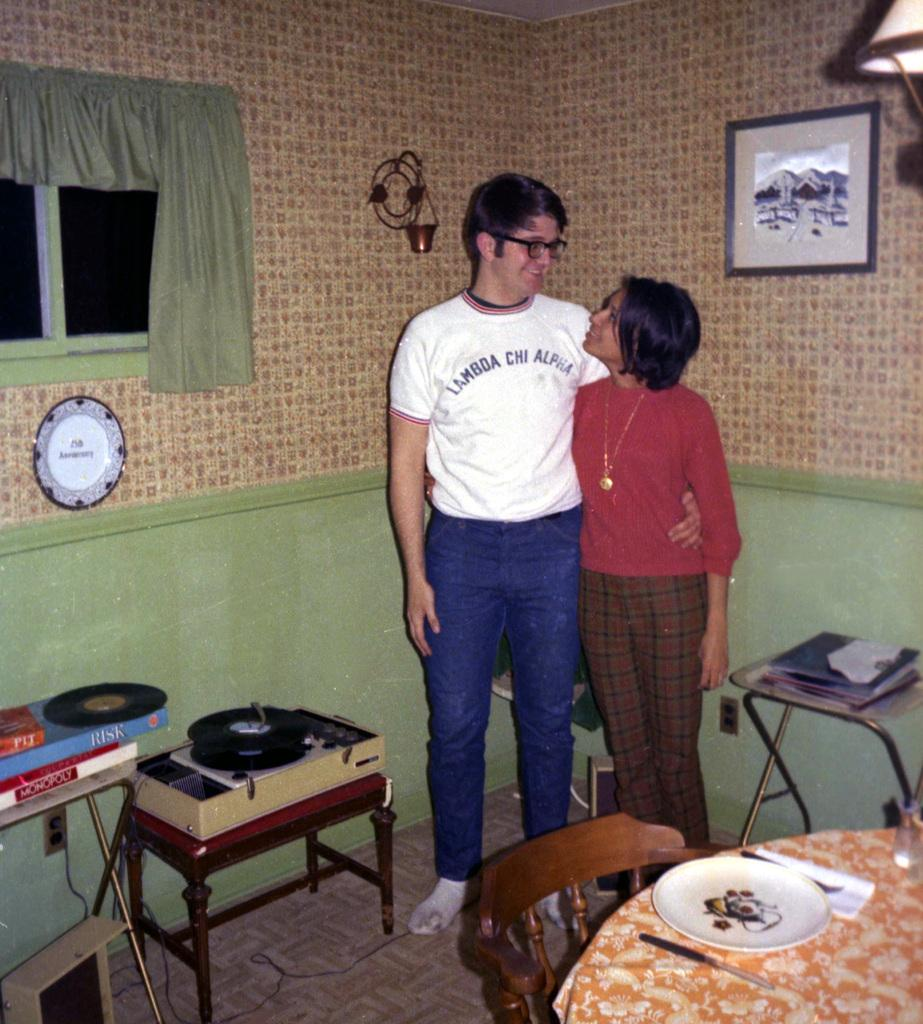<image>
Summarize the visual content of the image. A man wearing a Lambda Chi Alpha has his arm around a woman. 